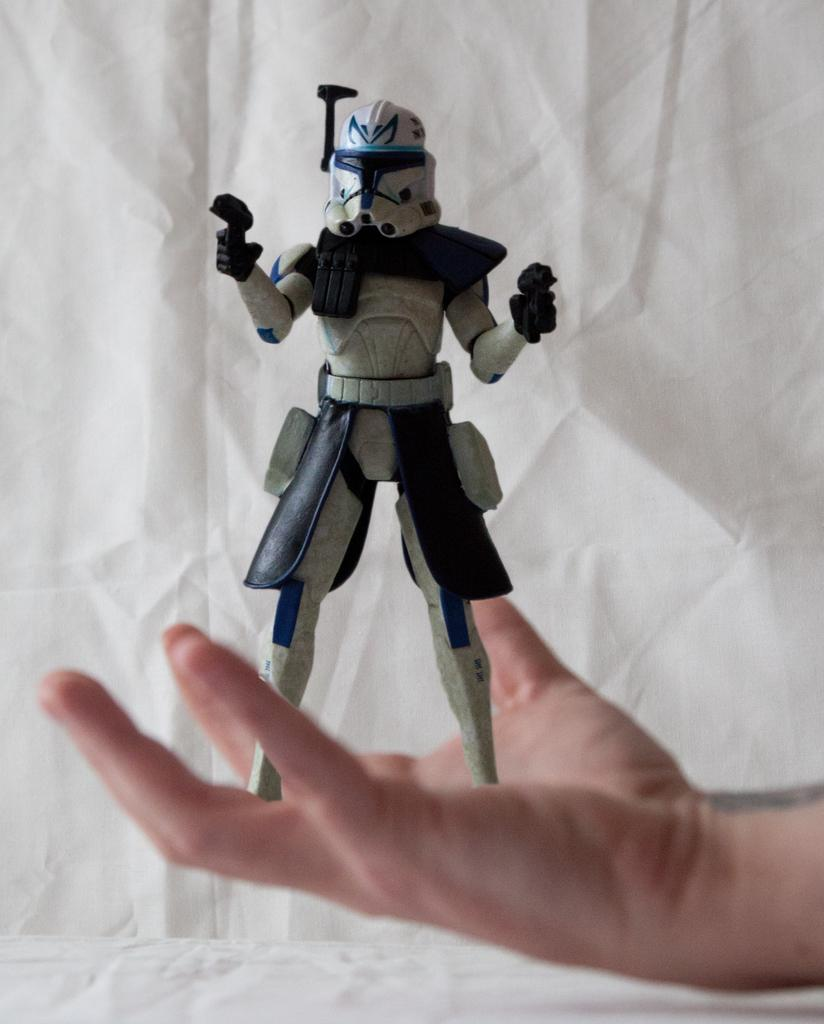What object is being held by a human hand in the image? There is a toy in the image, and a human hand is holding it. What can be seen in the background or surrounding the toy? There is a white color cloth visible in the image. How does the toy slip out of the frame in the image? The toy does not slip out of the frame in the image; it is being held by a human hand. Can you describe the sneeze of the person holding the toy in the image? There is no indication of a sneeze or any person in the image, as it only shows a toy being held by a hand. 